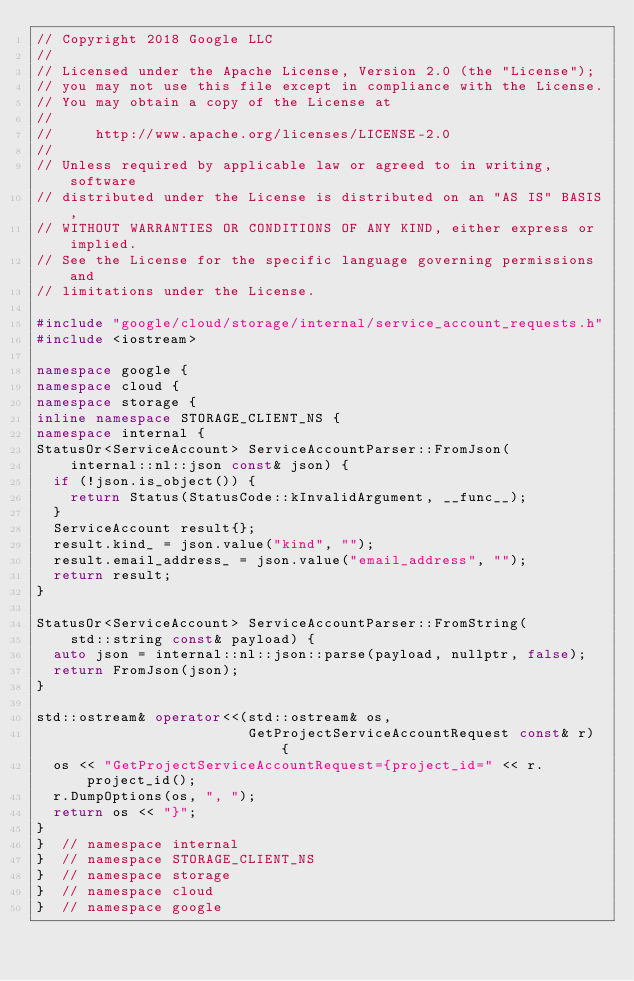<code> <loc_0><loc_0><loc_500><loc_500><_C++_>// Copyright 2018 Google LLC
//
// Licensed under the Apache License, Version 2.0 (the "License");
// you may not use this file except in compliance with the License.
// You may obtain a copy of the License at
//
//     http://www.apache.org/licenses/LICENSE-2.0
//
// Unless required by applicable law or agreed to in writing, software
// distributed under the License is distributed on an "AS IS" BASIS,
// WITHOUT WARRANTIES OR CONDITIONS OF ANY KIND, either express or implied.
// See the License for the specific language governing permissions and
// limitations under the License.

#include "google/cloud/storage/internal/service_account_requests.h"
#include <iostream>

namespace google {
namespace cloud {
namespace storage {
inline namespace STORAGE_CLIENT_NS {
namespace internal {
StatusOr<ServiceAccount> ServiceAccountParser::FromJson(
    internal::nl::json const& json) {
  if (!json.is_object()) {
    return Status(StatusCode::kInvalidArgument, __func__);
  }
  ServiceAccount result{};
  result.kind_ = json.value("kind", "");
  result.email_address_ = json.value("email_address", "");
  return result;
}

StatusOr<ServiceAccount> ServiceAccountParser::FromString(
    std::string const& payload) {
  auto json = internal::nl::json::parse(payload, nullptr, false);
  return FromJson(json);
}

std::ostream& operator<<(std::ostream& os,
                         GetProjectServiceAccountRequest const& r) {
  os << "GetProjectServiceAccountRequest={project_id=" << r.project_id();
  r.DumpOptions(os, ", ");
  return os << "}";
}
}  // namespace internal
}  // namespace STORAGE_CLIENT_NS
}  // namespace storage
}  // namespace cloud
}  // namespace google
</code> 